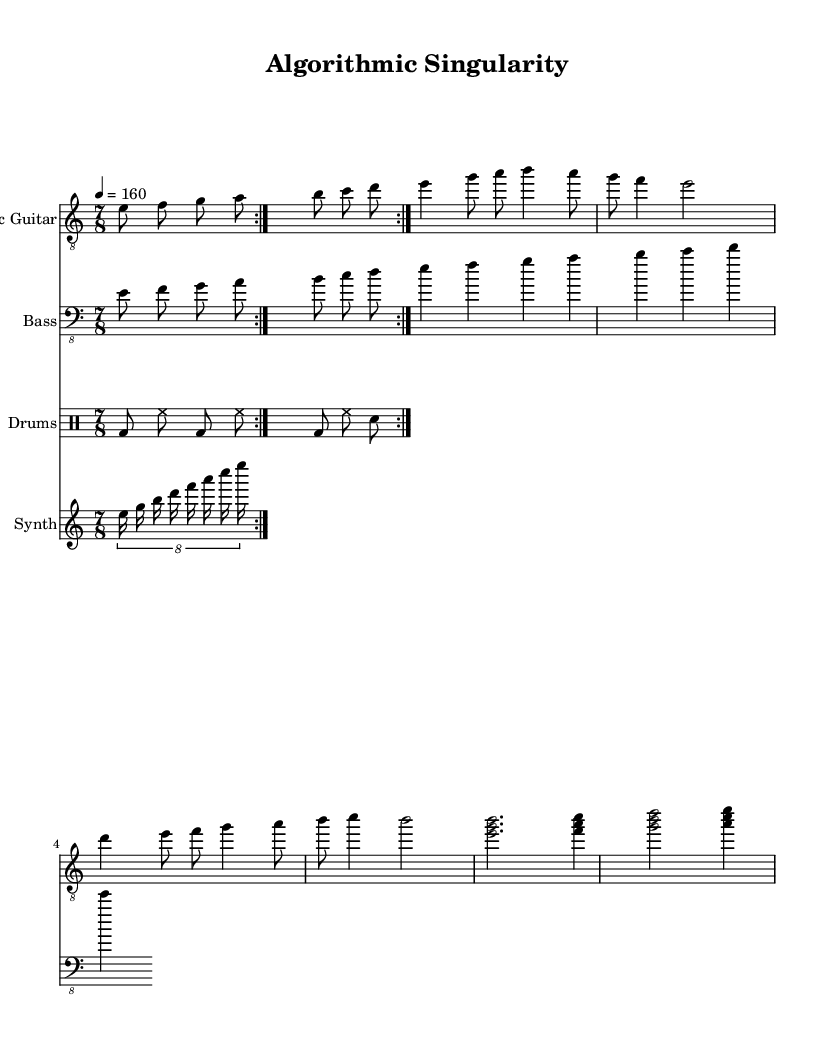What is the key signature of this music? The key signature is E Phrygian, which typically contains the notes E, F, G, A, B, C, and D, and is indicated at the start of the music.
Answer: E Phrygian What is the time signature of the piece? The time signature is 7/8, meaning there are 7 beats in each measure and the eighth note gets one beat. This can be found in the time signature marking at the beginning of the music.
Answer: 7/8 What is the tempo marking for this piece? The tempo marking is 160 beats per minute, specified as "4 = 160". This indicates how fast the piece should be played, found in the tempo marking at the beginning.
Answer: 160 How many times is the main riff repeated in the electric guitar part? The main riff is indicated to be repeated twice, as shown by the "volta" marking in the music. This is specifically noted where the main riff is introduced.
Answer: 2 What type of pattern is used in the synth part? The synth part utilizes a tuple pattern, specifically an 8 over 7 tuplet which effectively groups 8 notes within the time of 7. This construction adds to the complexity typical of progressive metal.
Answer: Tuplet What instruments are included in the score? The instruments included are Electric Guitar, Bass, Drums, and Synth. Each instrument is listed at the beginning of its respective staff in the score layout.
Answer: Electric Guitar, Bass, Drums, Synth What rhythmic pattern is used in the drum part? The drum part employs a repeating pattern featuring bass drum, hi-hat, and snare. This rhythmic structure is typical in metal music, where it maintains intensity.
Answer: Bass drum, hi-hat, snare 